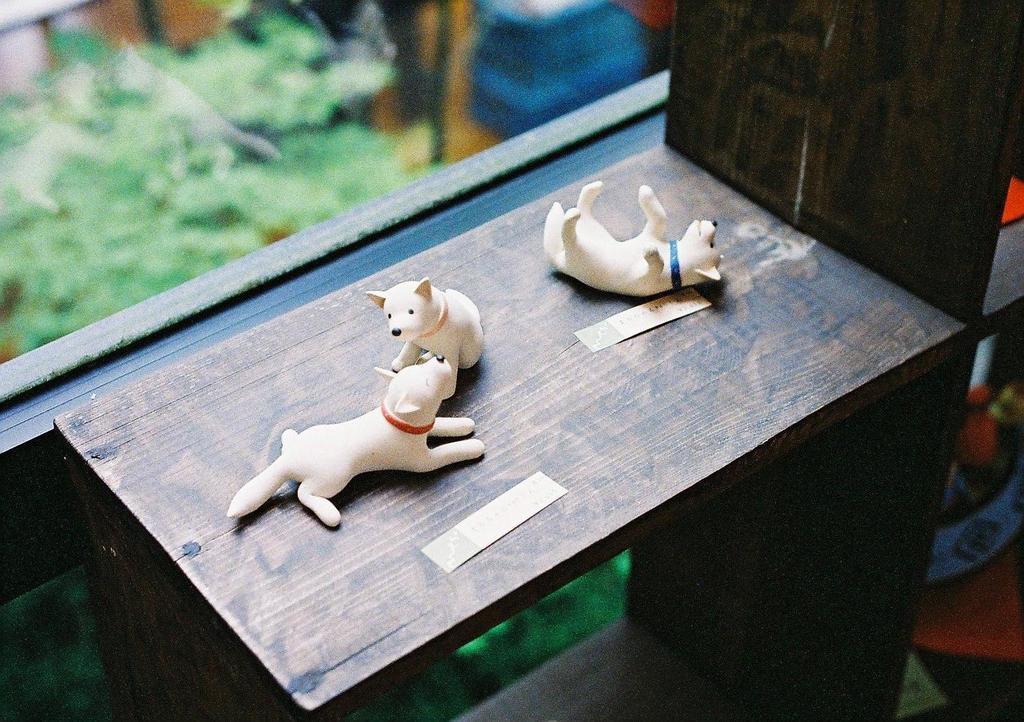Could you give a brief overview of what you see in this image? As we can see in a picture that, there are three toys in a wooden shelf. Beside is a window. 